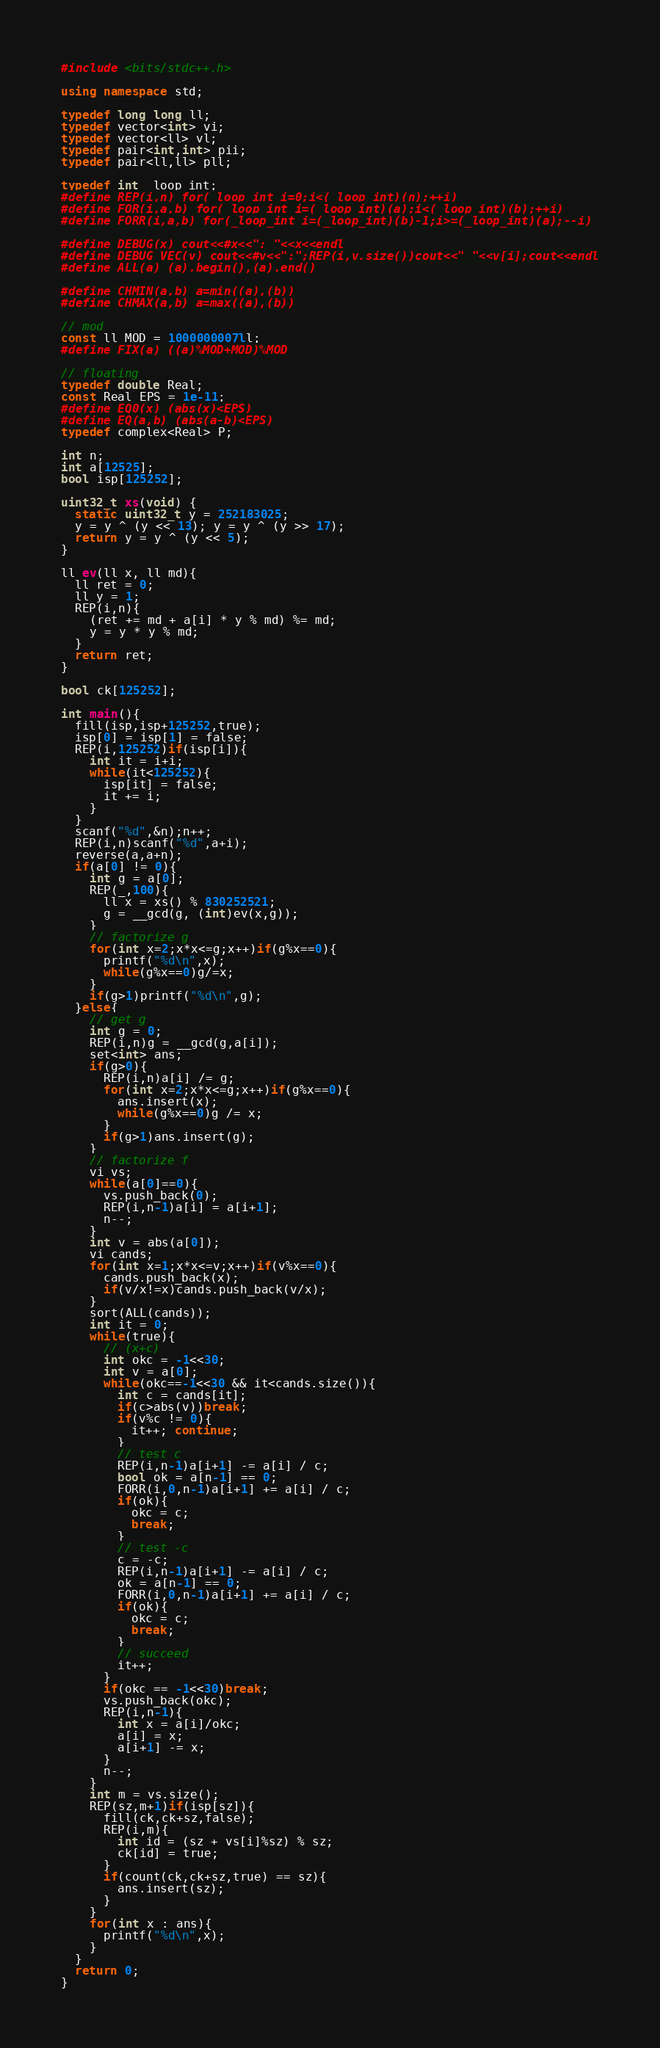<code> <loc_0><loc_0><loc_500><loc_500><_C++_>#include <bits/stdc++.h>

using namespace std;

typedef long long ll;
typedef vector<int> vi;
typedef vector<ll> vl;
typedef pair<int,int> pii;
typedef pair<ll,ll> pll;

typedef int _loop_int;
#define REP(i,n) for(_loop_int i=0;i<(_loop_int)(n);++i)
#define FOR(i,a,b) for(_loop_int i=(_loop_int)(a);i<(_loop_int)(b);++i)
#define FORR(i,a,b) for(_loop_int i=(_loop_int)(b)-1;i>=(_loop_int)(a);--i)

#define DEBUG(x) cout<<#x<<": "<<x<<endl
#define DEBUG_VEC(v) cout<<#v<<":";REP(i,v.size())cout<<" "<<v[i];cout<<endl
#define ALL(a) (a).begin(),(a).end()

#define CHMIN(a,b) a=min((a),(b))
#define CHMAX(a,b) a=max((a),(b))

// mod
const ll MOD = 1000000007ll;
#define FIX(a) ((a)%MOD+MOD)%MOD

// floating
typedef double Real;
const Real EPS = 1e-11;
#define EQ0(x) (abs(x)<EPS)
#define EQ(a,b) (abs(a-b)<EPS)
typedef complex<Real> P;

int n;
int a[12525];
bool isp[125252];

uint32_t xs(void) {
  static uint32_t y = 252183025;
  y = y ^ (y << 13); y = y ^ (y >> 17);
  return y = y ^ (y << 5);
}

ll ev(ll x, ll md){
  ll ret = 0;
  ll y = 1;
  REP(i,n){
    (ret += md + a[i] * y % md) %= md;
    y = y * y % md;
  }
  return ret;
}

bool ck[125252];

int main(){
  fill(isp,isp+125252,true);
  isp[0] = isp[1] = false;
  REP(i,125252)if(isp[i]){
    int it = i+i;
    while(it<125252){
      isp[it] = false;
      it += i;
    }
  }
  scanf("%d",&n);n++;
  REP(i,n)scanf("%d",a+i);
  reverse(a,a+n);
  if(a[0] != 0){
    int g = a[0];
    REP(_,100){
      ll x = xs() % 830252521;
      g = __gcd(g, (int)ev(x,g));
    }
    // factorize g
    for(int x=2;x*x<=g;x++)if(g%x==0){
      printf("%d\n",x);
      while(g%x==0)g/=x;
    }
    if(g>1)printf("%d\n",g);
  }else{
    // get g
    int g = 0;
    REP(i,n)g = __gcd(g,a[i]);
    set<int> ans;
    if(g>0){
      REP(i,n)a[i] /= g;
      for(int x=2;x*x<=g;x++)if(g%x==0){
        ans.insert(x);
        while(g%x==0)g /= x;
      }
      if(g>1)ans.insert(g);
    }
    // factorize f
    vi vs;
    while(a[0]==0){
      vs.push_back(0);
      REP(i,n-1)a[i] = a[i+1];
      n--;
    }
    int v = abs(a[0]);
    vi cands;
    for(int x=1;x*x<=v;x++)if(v%x==0){
      cands.push_back(x);
      if(v/x!=x)cands.push_back(v/x);
    }
    sort(ALL(cands));
    int it = 0;
    while(true){
      // (x+c)
      int okc = -1<<30;
      int v = a[0];
      while(okc==-1<<30 && it<cands.size()){
        int c = cands[it];
        if(c>abs(v))break;
        if(v%c != 0){
          it++; continue;
        }
        // test c
        REP(i,n-1)a[i+1] -= a[i] / c;
        bool ok = a[n-1] == 0;
        FORR(i,0,n-1)a[i+1] += a[i] / c;
        if(ok){
          okc = c;
          break;
        }
        // test -c
        c = -c;
        REP(i,n-1)a[i+1] -= a[i] / c;
        ok = a[n-1] == 0;
        FORR(i,0,n-1)a[i+1] += a[i] / c;
        if(ok){
          okc = c;
          break;
        }
        // succeed
        it++;
      }
      if(okc == -1<<30)break;
      vs.push_back(okc);
      REP(i,n-1){
        int x = a[i]/okc;
        a[i] = x;
        a[i+1] -= x;
      }
      n--;
    }
    int m = vs.size();
    REP(sz,m+1)if(isp[sz]){
      fill(ck,ck+sz,false);
      REP(i,m){
        int id = (sz + vs[i]%sz) % sz;
        ck[id] = true;
      }
      if(count(ck,ck+sz,true) == sz){
        ans.insert(sz);
      }
    }
    for(int x : ans){
      printf("%d\n",x);
    }
  }
  return 0;
}
</code> 